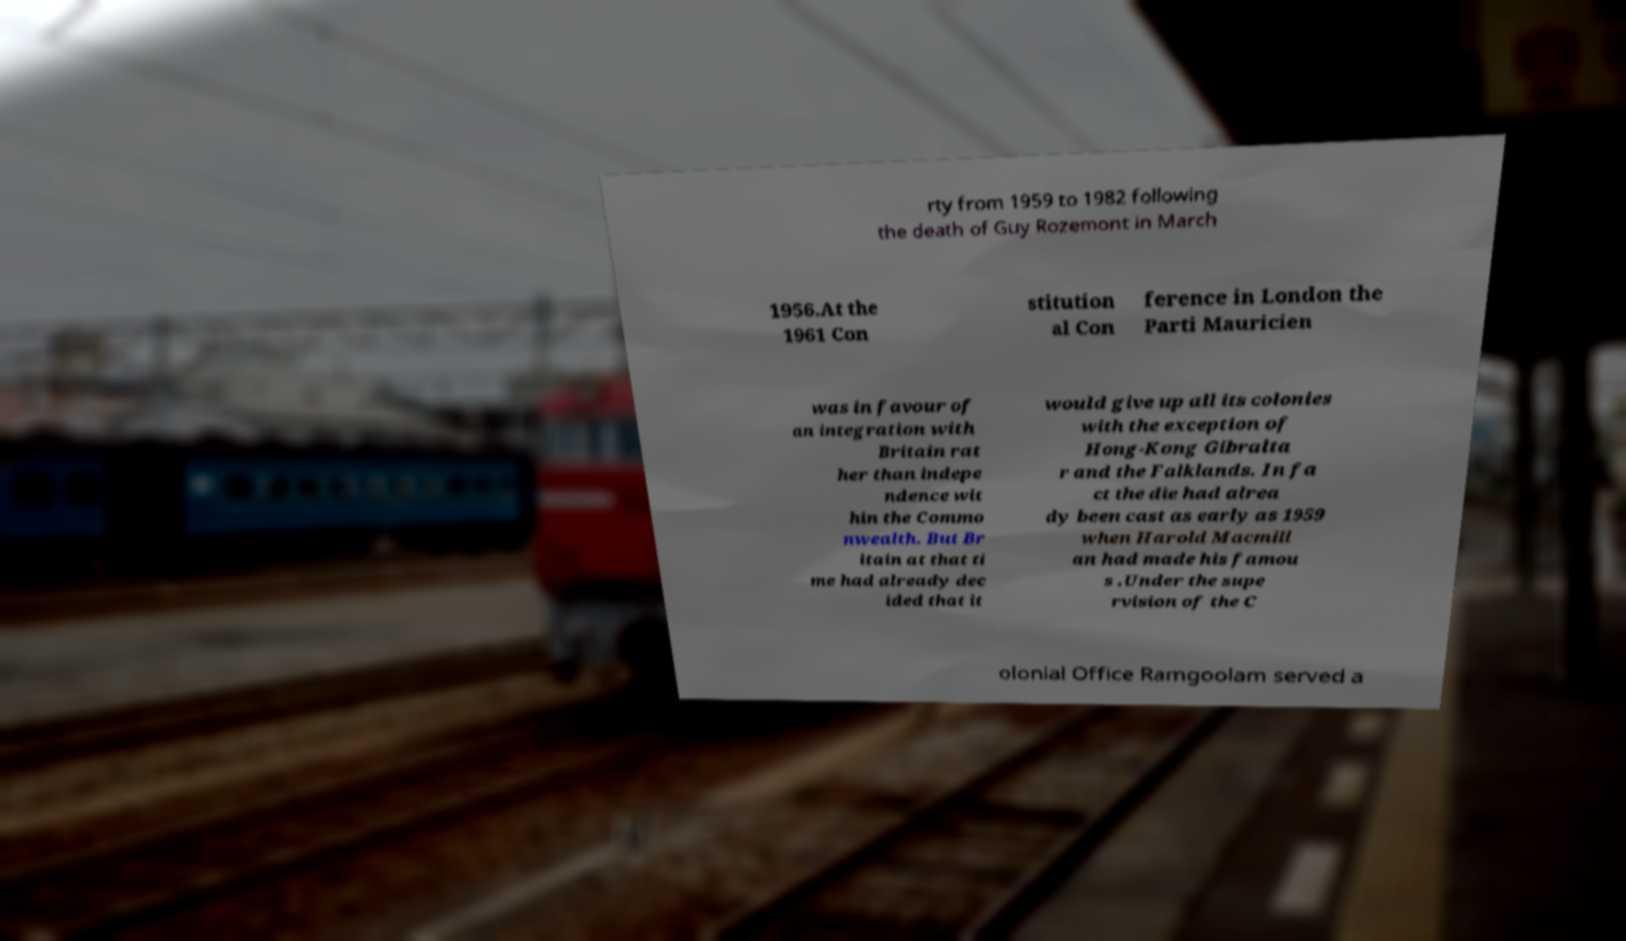There's text embedded in this image that I need extracted. Can you transcribe it verbatim? rty from 1959 to 1982 following the death of Guy Rozemont in March 1956.At the 1961 Con stitution al Con ference in London the Parti Mauricien was in favour of an integration with Britain rat her than indepe ndence wit hin the Commo nwealth. But Br itain at that ti me had already dec ided that it would give up all its colonies with the exception of Hong-Kong Gibralta r and the Falklands. In fa ct the die had alrea dy been cast as early as 1959 when Harold Macmill an had made his famou s .Under the supe rvision of the C olonial Office Ramgoolam served a 